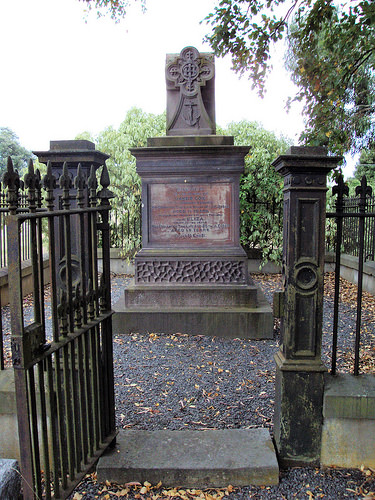<image>
Is the gate next to the rock? Yes. The gate is positioned adjacent to the rock, located nearby in the same general area. 